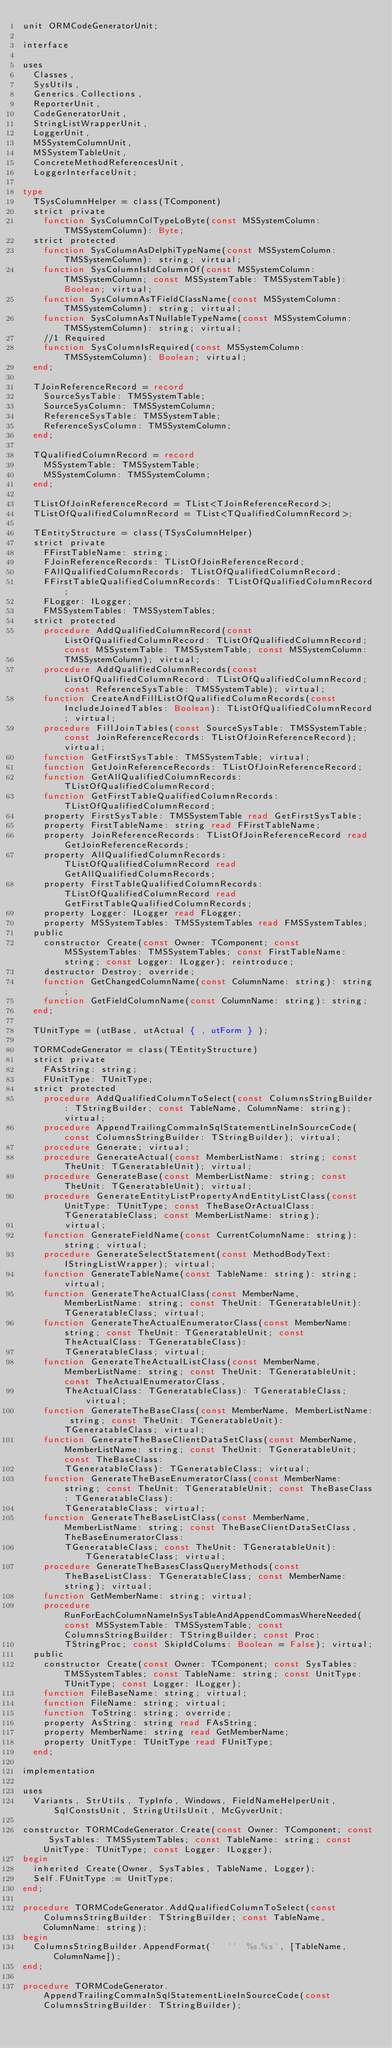Convert code to text. <code><loc_0><loc_0><loc_500><loc_500><_Pascal_>unit ORMCodeGeneratorUnit;

interface

uses
  Classes,
  SysUtils,
  Generics.Collections,
  ReporterUnit,
  CodeGeneratorUnit,
  StringListWrapperUnit,
  LoggerUnit,
  MSSystemColumnUnit,
  MSSystemTableUnit,
  ConcreteMethodReferencesUnit,
  LoggerInterfaceUnit;

type
  TSysColumnHelper = class(TComponent)
  strict private
    function SysColumnColTypeLoByte(const MSSystemColumn: TMSSystemColumn): Byte;
  strict protected
    function SysColumnAsDelphiTypeName(const MSSystemColumn: TMSSystemColumn): string; virtual;
    function SysColumnIsIdColumnOf(const MSSystemColumn: TMSSystemColumn; const MSSystemTable: TMSSystemTable): Boolean; virtual;
    function SysColumnAsTFieldClassName(const MSSystemColumn: TMSSystemColumn): string; virtual;
    function SysColumnAsTNullableTypeName(const MSSystemColumn: TMSSystemColumn): string; virtual;
    //1 Required
    function SysColumnIsRequired(const MSSystemColumn: TMSSystemColumn): Boolean; virtual;
  end;

  TJoinReferenceRecord = record
    SourceSysTable: TMSSystemTable;
    SourceSysColumn: TMSSystemColumn;
    ReferenceSysTable: TMSSystemTable;
    ReferenceSysColumn: TMSSystemColumn;
  end;

  TQualifiedColumnRecord = record
    MSSystemTable: TMSSystemTable;
    MSSystemColumn: TMSSystemColumn;
  end;

  TListOfJoinReferenceRecord = TList<TJoinReferenceRecord>;
  TListOfQualifiedColumnRecord = TList<TQualifiedColumnRecord>;

  TEntityStructure = class(TSysColumnHelper)
  strict private
    FFirstTableName: string;
    FJoinReferenceRecords: TListOfJoinReferenceRecord;
    FAllQualifiedColumnRecords: TListOfQualifiedColumnRecord;
    FFirstTableQualifiedColumnRecords: TListOfQualifiedColumnRecord;
    FLogger: ILogger;
    FMSSystemTables: TMSSystemTables;
  strict protected
    procedure AddQualifiedColumnRecord(const ListOfQualifiedColumnRecord: TListOfQualifiedColumnRecord; const MSSystemTable: TMSSystemTable; const MSSystemColumn:
        TMSSystemColumn); virtual;
    procedure AddQualifiedColumnRecords(const ListOfQualifiedColumnRecord: TListOfQualifiedColumnRecord; const ReferenceSysTable: TMSSystemTable); virtual;
    function CreateAndFillListOfQualifiedColumnRecords(const IncludeJoinedTables: Boolean): TListOfQualifiedColumnRecord; virtual;
    procedure FillJoinTables(const SourceSysTable: TMSSystemTable; const JoinReferenceRecords: TListOfJoinReferenceRecord); virtual;
    function GetFirstSysTable: TMSSystemTable; virtual;
    function GetJoinReferenceRecords: TListOfJoinReferenceRecord;
    function GetAllQualifiedColumnRecords: TListOfQualifiedColumnRecord;
    function GetFirstTableQualifiedColumnRecords: TListOfQualifiedColumnRecord;
    property FirstSysTable: TMSSystemTable read GetFirstSysTable;
    property FirstTableName: string read FFirstTableName;
    property JoinReferenceRecords: TListOfJoinReferenceRecord read GetJoinReferenceRecords;
    property AllQualifiedColumnRecords: TListOfQualifiedColumnRecord read GetAllQualifiedColumnRecords;
    property FirstTableQualifiedColumnRecords: TListOfQualifiedColumnRecord read GetFirstTableQualifiedColumnRecords;
    property Logger: ILogger read FLogger;
    property MSSystemTables: TMSSystemTables read FMSSystemTables;
  public
    constructor Create(const Owner: TComponent; const MSSystemTables: TMSSystemTables; const FirstTableName: string; const Logger: ILogger); reintroduce;
    destructor Destroy; override;
    function GetChangedColumnName(const ColumnName: string): string;
    function GetFieldColumnName(const ColumnName: string): string;
  end;

  TUnitType = (utBase, utActual { , utForm } );

  TORMCodeGenerator = class(TEntityStructure)
  strict private
    FAsString: string;
    FUnitType: TUnitType;
  strict protected
    procedure AddQualifiedColumnToSelect(const ColumnsStringBuilder: TStringBuilder; const TableName, ColumnName: string); virtual;
    procedure AppendTrailingCommaInSqlStatementLineInSourceCode(const ColumnsStringBuilder: TStringBuilder); virtual;
    procedure Generate; virtual;
    procedure GenerateActual(const MemberListName: string; const TheUnit: TGeneratableUnit); virtual;
    procedure GenerateBase(const MemberListName: string; const TheUnit: TGeneratableUnit); virtual;
    procedure GenerateEntityListPropertyAndEntityListClass(const UnitType: TUnitType; const TheBaseOrActualClass: TGeneratableClass; const MemberListName: string);
        virtual;
    function GenerateFieldName(const CurrentColumnName: string): string; virtual;
    procedure GenerateSelectStatement(const MethodBodyText: IStringListWrapper); virtual;
    function GenerateTableName(const TableName: string): string; virtual;
    function GenerateTheActualClass(const MemberName, MemberListName: string; const TheUnit: TGeneratableUnit): TGeneratableClass; virtual;
    function GenerateTheActualEnumeratorClass(const MemberName: string; const TheUnit: TGeneratableUnit; const TheActualClass: TGeneratableClass):
        TGeneratableClass; virtual;
    function GenerateTheActualListClass(const MemberName, MemberListName: string; const TheUnit: TGeneratableUnit; const TheActualEnumeratorClass,
        TheActualClass: TGeneratableClass): TGeneratableClass; virtual;
    function GenerateTheBaseClass(const MemberName, MemberListName: string; const TheUnit: TGeneratableUnit): TGeneratableClass; virtual;
    function GenerateTheBaseClientDataSetClass(const MemberName, MemberListName: string; const TheUnit: TGeneratableUnit; const TheBaseClass:
        TGeneratableClass): TGeneratableClass; virtual;
    function GenerateTheBaseEnumeratorClass(const MemberName: string; const TheUnit: TGeneratableUnit; const TheBaseClass: TGeneratableClass):
        TGeneratableClass; virtual;
    function GenerateTheBaseListClass(const MemberName, MemberListName: string; const TheBaseClientDataSetClass, TheBaseEnumeratorClass:
        TGeneratableClass; const TheUnit: TGeneratableUnit): TGeneratableClass; virtual;
    procedure GenerateTheBasesClassQueryMethods(const TheBaseListClass: TGeneratableClass; const MemberName: string); virtual;
    function GetMemberName: string; virtual;
    procedure RunForEachColumnNameInSysTableAndAppendCommasWhereNeeded(const MSSystemTable: TMSSystemTable; const ColumnsStringBuilder: TStringBuilder; const Proc:
        TStringProc; const SkipIdColums: Boolean = False); virtual;
  public
    constructor Create(const Owner: TComponent; const SysTables: TMSSystemTables; const TableName: string; const UnitType: TUnitType; const Logger: ILogger);
    function FileBaseName: string; virtual;
    function FileName: string; virtual;
    function ToString: string; override;
    property AsString: string read FAsString;
    property MemberName: string read GetMemberName;
    property UnitType: TUnitType read FUnitType;
  end;

implementation

uses
  Variants, StrUtils, TypInfo, Windows, FieldNameHelperUnit, SqlConstsUnit, StringUtilsUnit, McGyverUnit;

constructor TORMCodeGenerator.Create(const Owner: TComponent; const SysTables: TMSSystemTables; const TableName: string; const UnitType: TUnitType; const Logger: ILogger);
begin
  inherited Create(Owner, SysTables, TableName, Logger);
  Self.FUnitType := UnitType;
end;

procedure TORMCodeGenerator.AddQualifiedColumnToSelect(const ColumnsStringBuilder: TStringBuilder; const TableName, ColumnName: string);
begin
  ColumnsStringBuilder.AppendFormat('  ''  %s.%s', [TableName, ColumnName]);
end;

procedure TORMCodeGenerator.AppendTrailingCommaInSqlStatementLineInSourceCode(const ColumnsStringBuilder: TStringBuilder);</code> 